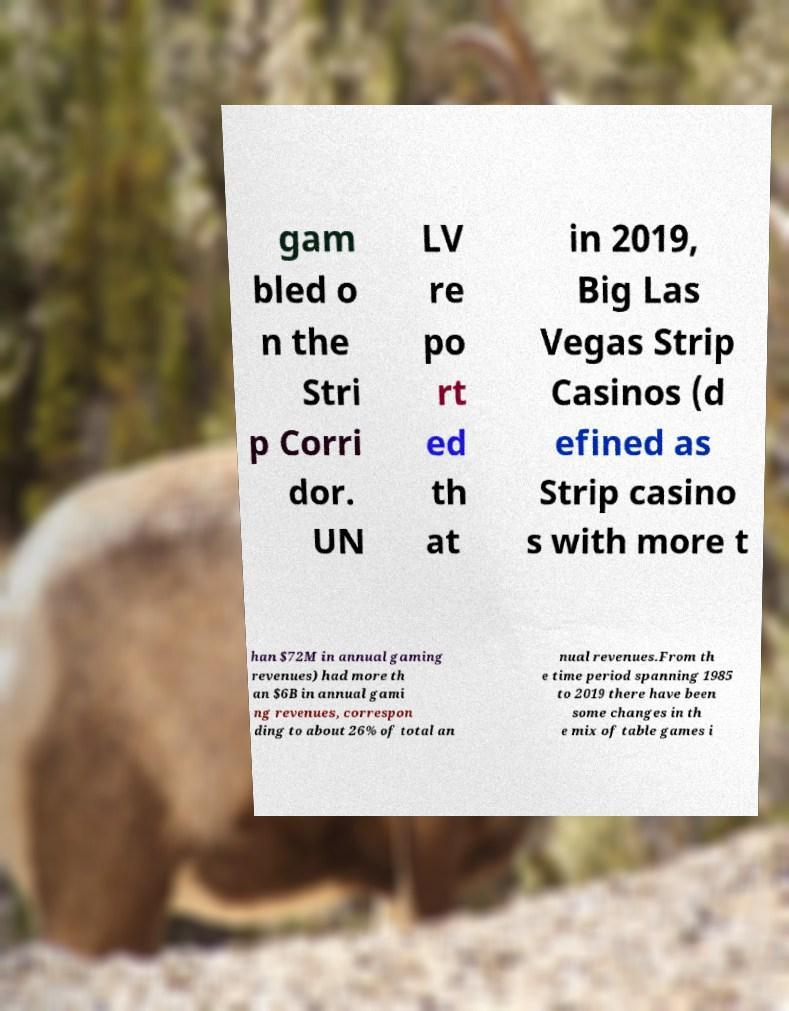Please identify and transcribe the text found in this image. gam bled o n the Stri p Corri dor. UN LV re po rt ed th at in 2019, Big Las Vegas Strip Casinos (d efined as Strip casino s with more t han $72M in annual gaming revenues) had more th an $6B in annual gami ng revenues, correspon ding to about 26% of total an nual revenues.From th e time period spanning 1985 to 2019 there have been some changes in th e mix of table games i 